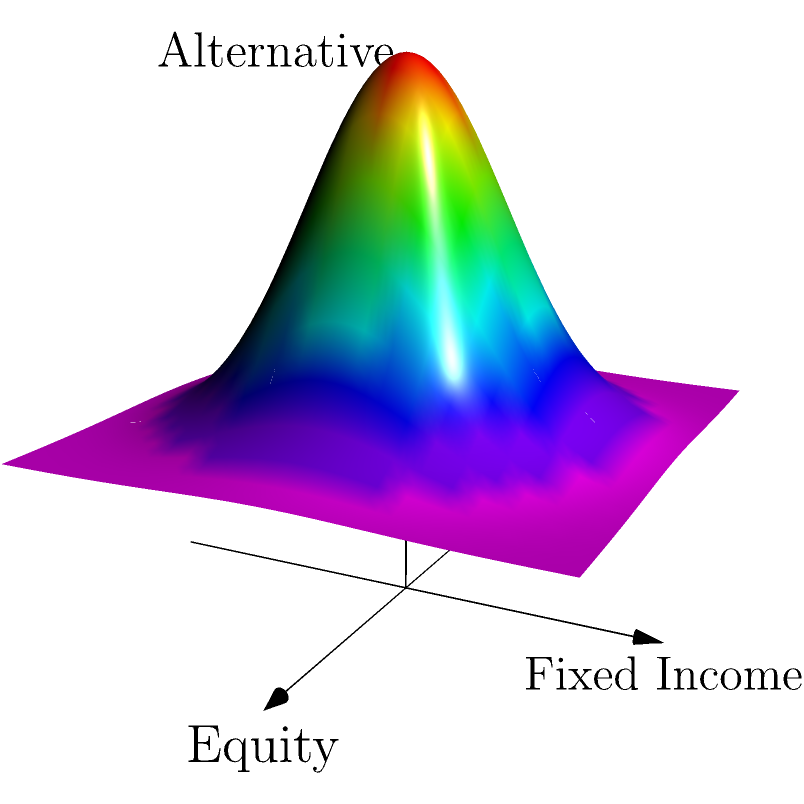In the topological representation of a multi-dimensional asset allocation strategy shown above, which dimension appears to have the highest peak, indicating the highest potential return or risk? To answer this question, we need to analyze the 3D surface plot representing the asset allocation strategy:

1. The x-axis represents Equity allocation.
2. The y-axis represents Fixed Income allocation.
3. The z-axis represents Alternative investments allocation.

4. The surface's height (z-value) indicates the potential return or risk associated with different combinations of asset allocations.

5. Observing the surface, we can see that it forms a symmetrical peak at the center of the x-y plane.

6. This central peak suggests that a balanced allocation among all three asset classes (Equity, Fixed Income, and Alternative) yields the highest potential return or risk.

7. The peak is directly above the origin (0,0) in the x-y plane, indicating equal allocation to Equity and Fixed Income.

8. The z-axis (Alternative investments) contributes to the height of this peak, suggesting that including alternative investments in a balanced portfolio can potentially increase returns or risk.

Therefore, the dimension that appears to have the highest peak is the z-axis, representing Alternative investments, as it contributes to the maximum height of the surface above a balanced allocation of Equity and Fixed Income.
Answer: Alternative investments 